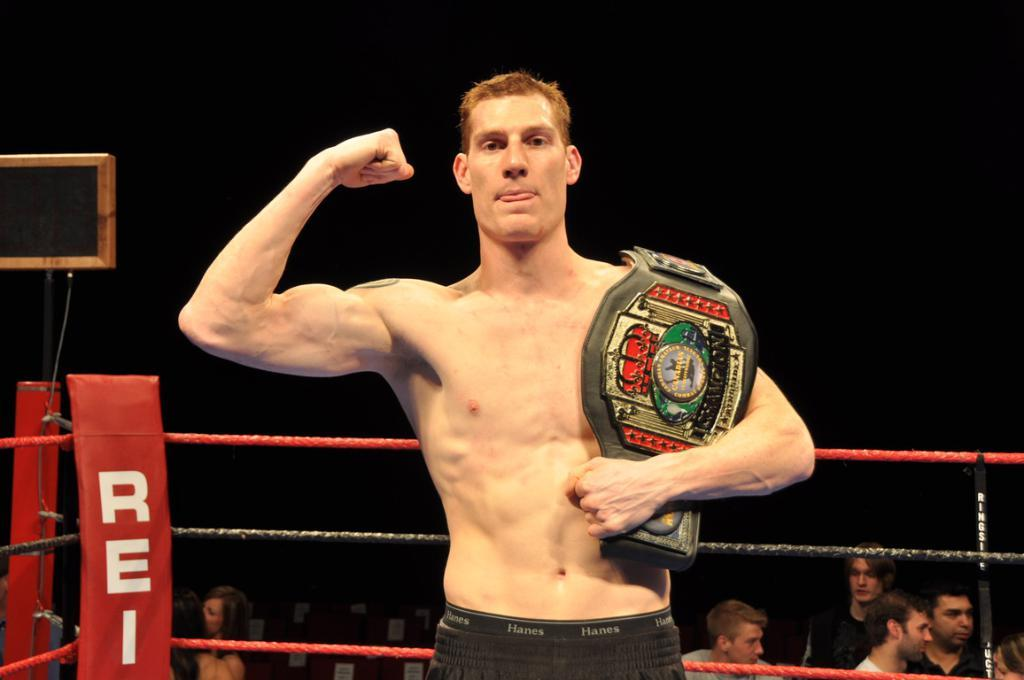<image>
Offer a succinct explanation of the picture presented. The red corner of the ring says REI on it 